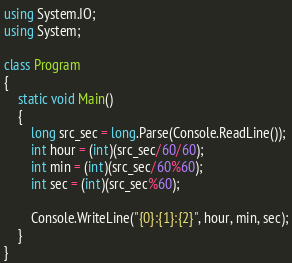Convert code to text. <code><loc_0><loc_0><loc_500><loc_500><_C#_>using System.IO;
using System;

class Program
{
    static void Main()
    {
        long src_sec = long.Parse(Console.ReadLine());
        int hour = (int)(src_sec/60/60);
        int min = (int)(src_sec/60%60);
        int sec = (int)(src_sec%60);

        Console.WriteLine("{0}:{1}:{2}", hour, min, sec);
    }
}</code> 